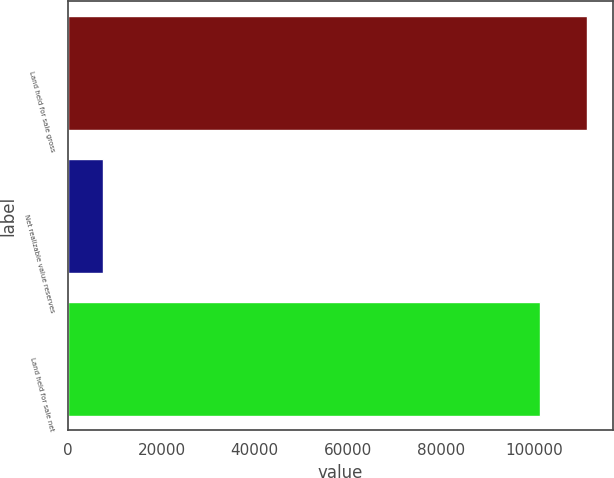Convert chart to OTSL. <chart><loc_0><loc_0><loc_500><loc_500><bar_chart><fcel>Land held for sale gross<fcel>Net realizable value reserves<fcel>Land held for sale net<nl><fcel>111309<fcel>7535<fcel>101190<nl></chart> 